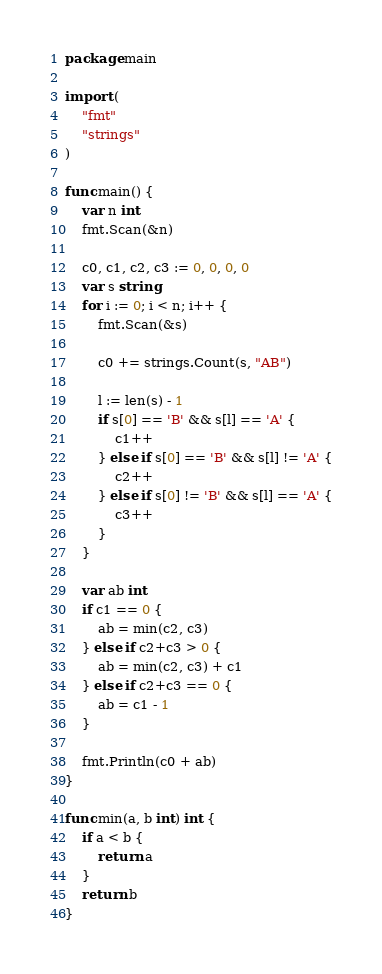<code> <loc_0><loc_0><loc_500><loc_500><_Go_>package main

import (
	"fmt"
	"strings"
)

func main() {
	var n int
	fmt.Scan(&n)

	c0, c1, c2, c3 := 0, 0, 0, 0
	var s string
	for i := 0; i < n; i++ {
		fmt.Scan(&s)

		c0 += strings.Count(s, "AB")

		l := len(s) - 1
		if s[0] == 'B' && s[l] == 'A' {
			c1++
		} else if s[0] == 'B' && s[l] != 'A' {
			c2++
		} else if s[0] != 'B' && s[l] == 'A' {
			c3++
		}
	}

	var ab int
	if c1 == 0 {
		ab = min(c2, c3)
	} else if c2+c3 > 0 {
		ab = min(c2, c3) + c1
	} else if c2+c3 == 0 {
		ab = c1 - 1
	}

	fmt.Println(c0 + ab)
}

func min(a, b int) int {
	if a < b {
		return a
	}
	return b
}
</code> 